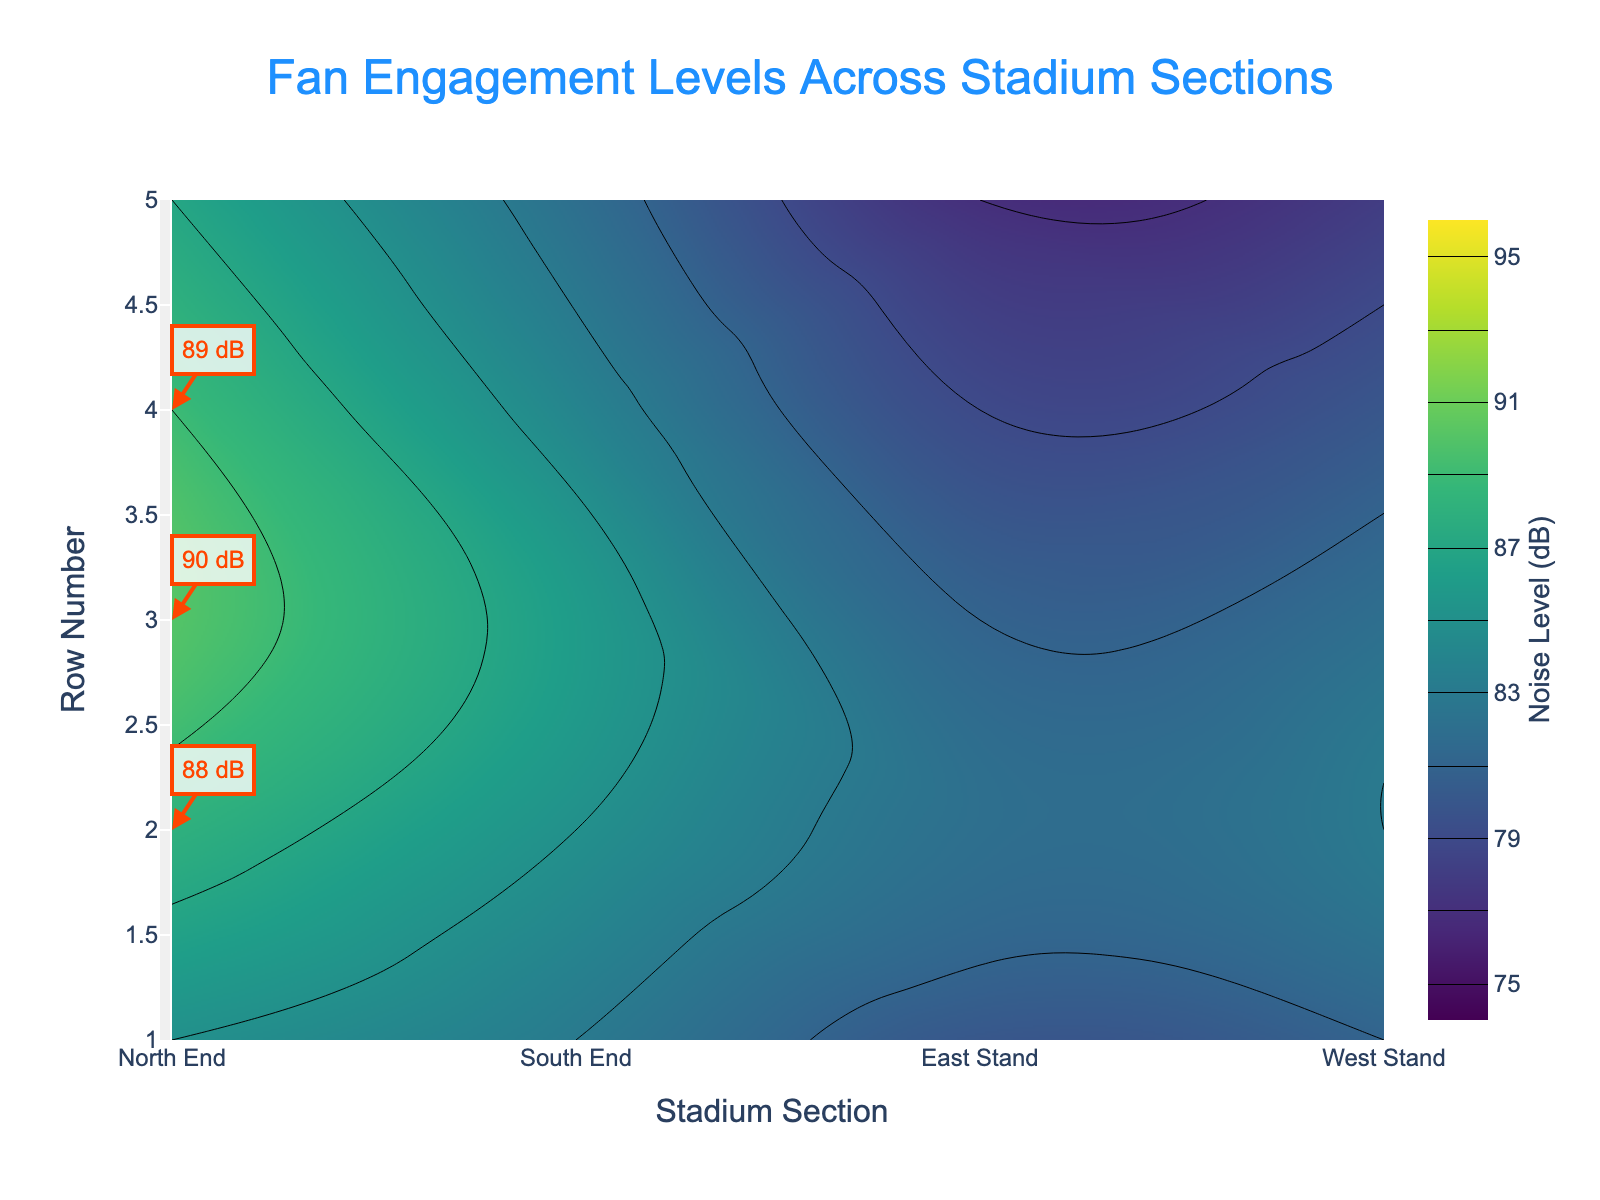What is the title of the figure? The title is located at the top of the figure. By examining this area, you can see the text that describes the content of the plot.
Answer: Fan Engagement Levels Across Stadium Sections Which stadium section has the highest noise levels? Look at the contour plot and identify the section with the highest decibel readings. The highest levels are often indicated by the darkest or the most intense color bands.
Answer: North End What is the noise level at Row 3 in the South End section? Locate the South End section on the x-axis and Row 3 on the y-axis, then trace to the corresponding contour value in decibels.
Answer: 86 dB Compare the noise levels between Row 1 in both the North End and the East Stand. Which one is higher? Find Row 1 in the North End and East Stand sections along the y-axis and compare their noise levels given by the contour color or the annotated values.
Answer: North End What is the average noise level across Row 2 in all sections? Identify the noise levels for Row 2 in each section (North End, South End, East Stand, and West Stand). Sum these noise levels and divide by the number of sections to get the average. (88 + 85 + 82 + 83)/4 = 84.5
Answer: 84.5 dB Which section and row combination is identified as a hotspot with 90 dB of noise level? Check the annotations that highlight hotspots with noise levels and find the one with 90 dB.
Answer: North End, Row 3 Is there a section where the noise level consistently decreases as rows increase? Examine the contour levels from Row 1 to Row 5 within each section and look for a consistent decrease in noise levels. The East Stand shows this trend.
Answer: East Stand Among the South End and West Stand sections, which has a higher average noise level? Calculate the average noise level for both South End and West Stand by summing their noise levels across all rows and dividing by 5. Compare the two averages. South End: (83 + 85 + 86 + 84 + 82)/5 = 84; West Stand: (81 + 83 + 82 + 80 + 78)/5 = 80.8
Answer: South End What is the range of noise levels in the West Stand section? Identify the highest and lowest noise levels in the West Stand section and subtract the lowest from the highest. The highest is 83 dB and the lowest is 78 dB.
Answer: 5 dB Which rows in the North End section have noise levels above 88 dB? Look at the contour levels for the North End section and find rows with noise decibels exceeding 88 dB.
Answer: Rows 2, 3, 4 